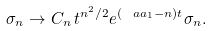<formula> <loc_0><loc_0><loc_500><loc_500>\sigma _ { n } \rightarrow C _ { n } \, t ^ { n ^ { 2 } / 2 } e ^ { ( \ a a _ { 1 } - n ) t } \sigma _ { n } .</formula> 